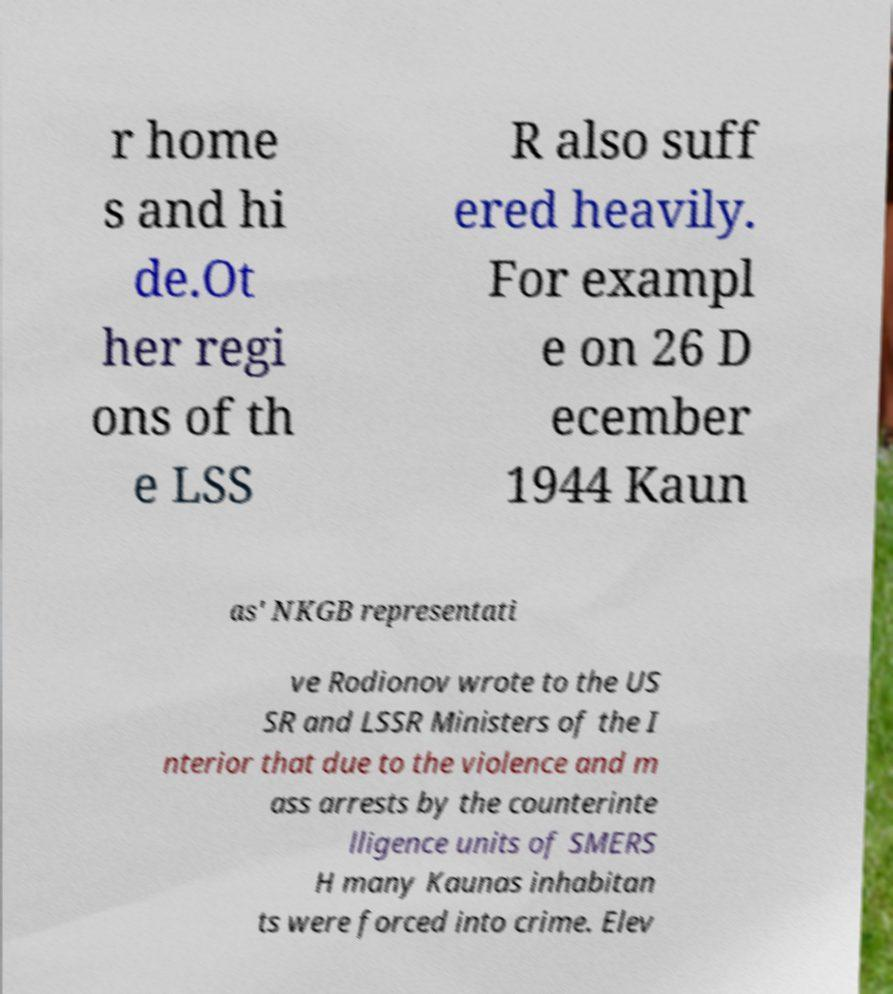There's text embedded in this image that I need extracted. Can you transcribe it verbatim? r home s and hi de.Ot her regi ons of th e LSS R also suff ered heavily. For exampl e on 26 D ecember 1944 Kaun as' NKGB representati ve Rodionov wrote to the US SR and LSSR Ministers of the I nterior that due to the violence and m ass arrests by the counterinte lligence units of SMERS H many Kaunas inhabitan ts were forced into crime. Elev 